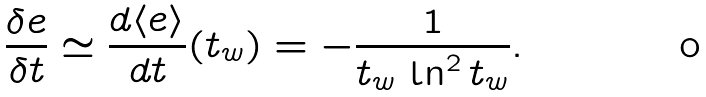<formula> <loc_0><loc_0><loc_500><loc_500>\frac { \delta e } { \delta t } \simeq \frac { d \langle e \rangle } { d t } ( t _ { w } ) = - \frac { 1 } { t _ { w } \, \ln ^ { 2 } t _ { w } } .</formula> 